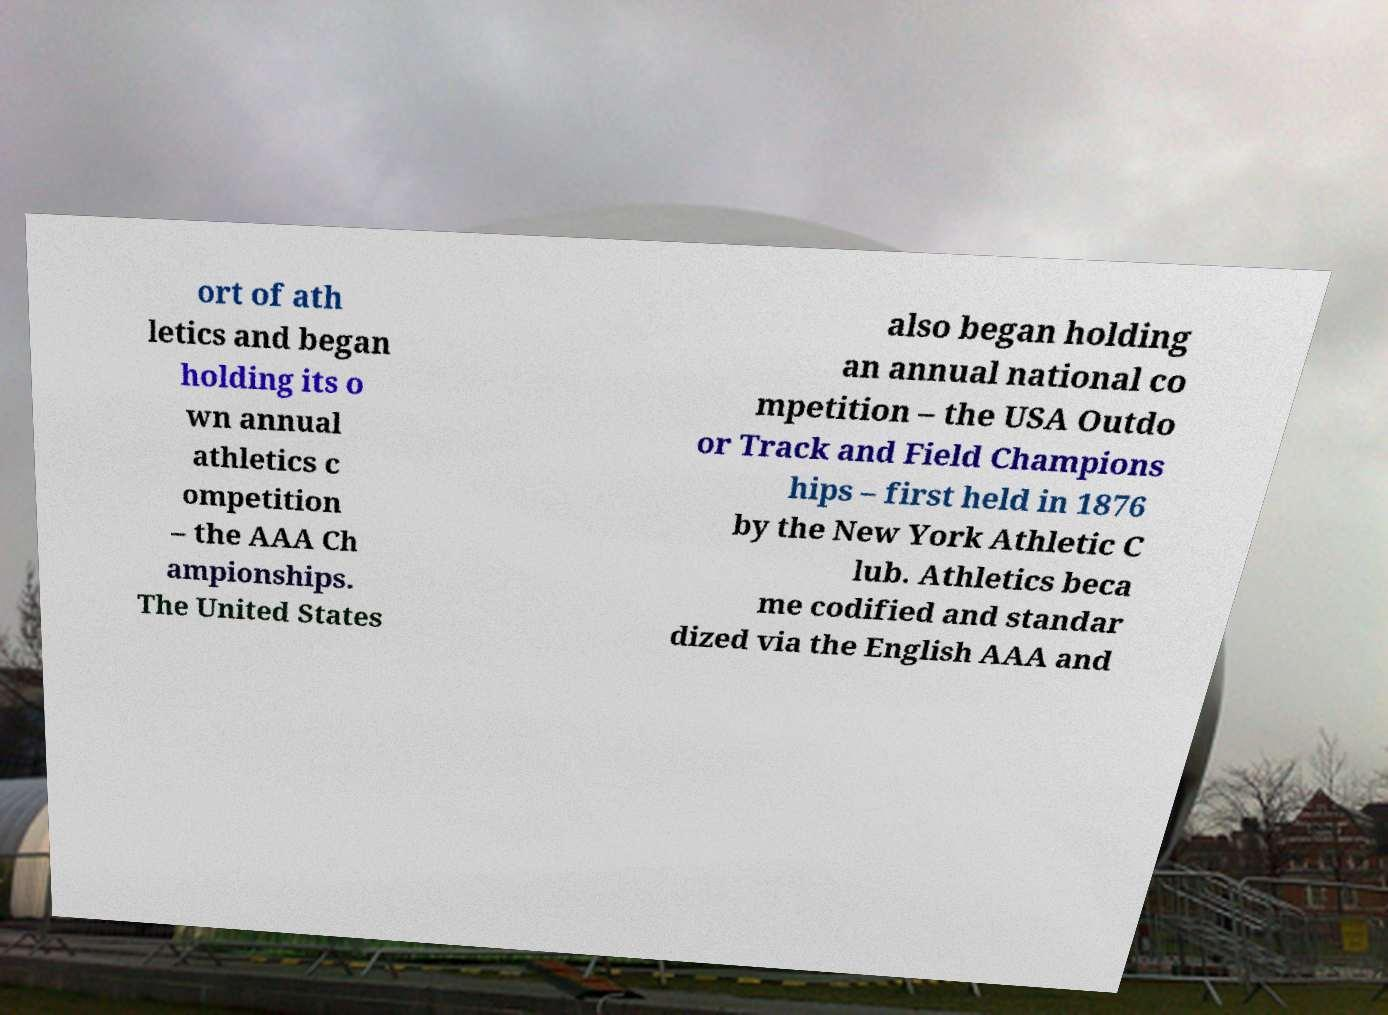There's text embedded in this image that I need extracted. Can you transcribe it verbatim? ort of ath letics and began holding its o wn annual athletics c ompetition – the AAA Ch ampionships. The United States also began holding an annual national co mpetition – the USA Outdo or Track and Field Champions hips – first held in 1876 by the New York Athletic C lub. Athletics beca me codified and standar dized via the English AAA and 